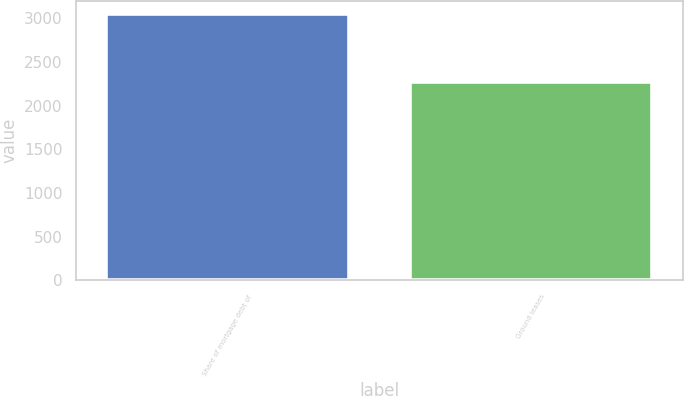<chart> <loc_0><loc_0><loc_500><loc_500><bar_chart><fcel>Share of mortgage debt of<fcel>Ground leases<nl><fcel>3047<fcel>2275<nl></chart> 